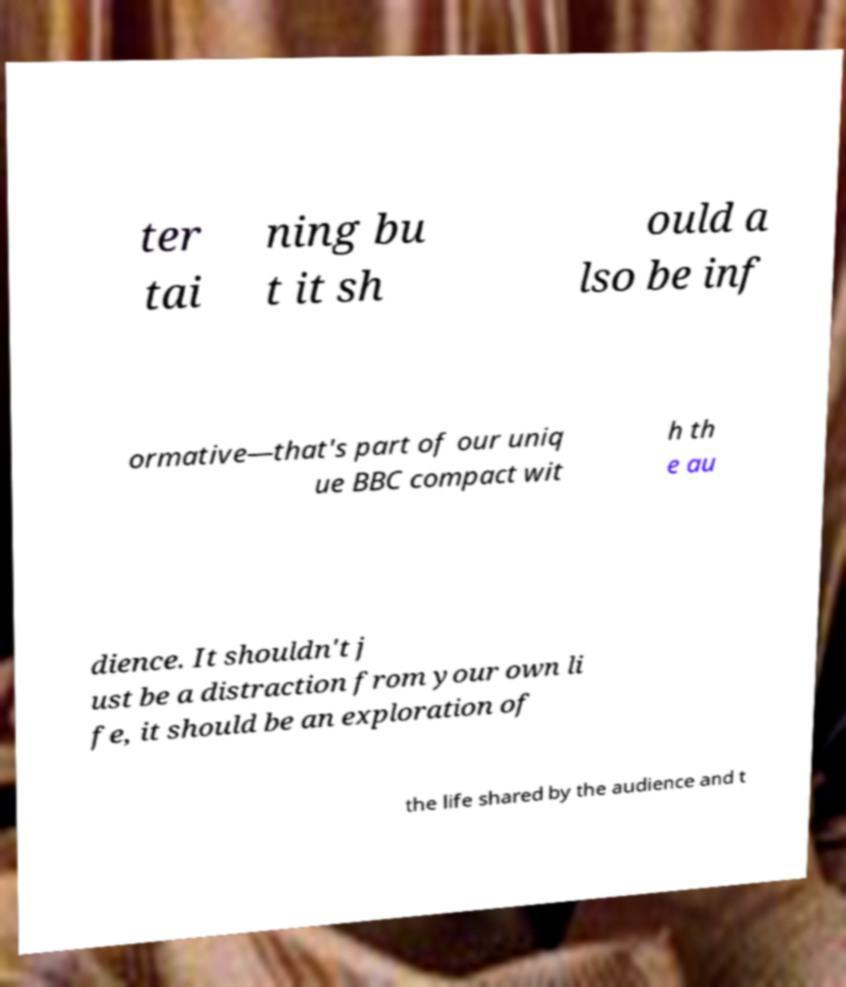What messages or text are displayed in this image? I need them in a readable, typed format. ter tai ning bu t it sh ould a lso be inf ormative—that's part of our uniq ue BBC compact wit h th e au dience. It shouldn't j ust be a distraction from your own li fe, it should be an exploration of the life shared by the audience and t 